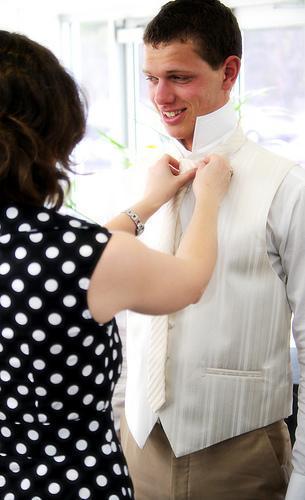How many people are there?
Give a very brief answer. 2. How many women are there?
Give a very brief answer. 1. 